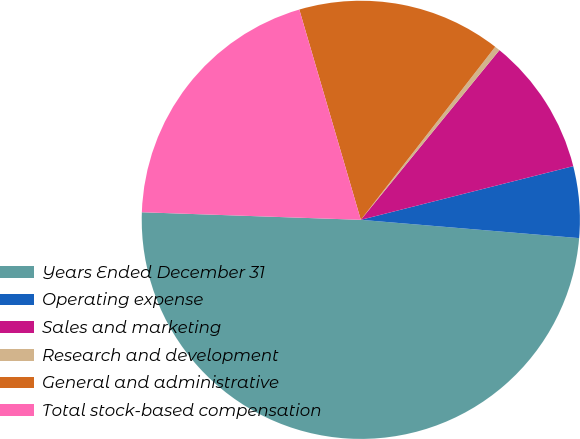<chart> <loc_0><loc_0><loc_500><loc_500><pie_chart><fcel>Years Ended December 31<fcel>Operating expense<fcel>Sales and marketing<fcel>Research and development<fcel>General and administrative<fcel>Total stock-based compensation<nl><fcel>49.22%<fcel>5.27%<fcel>10.16%<fcel>0.39%<fcel>15.04%<fcel>19.92%<nl></chart> 